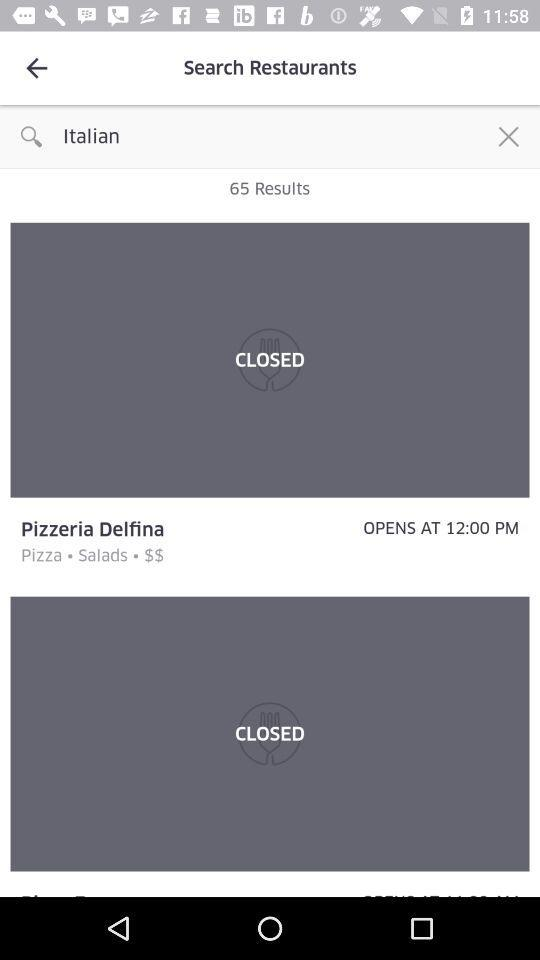How many results are there for Italian restaurants?
Answer the question using a single word or phrase. 65 